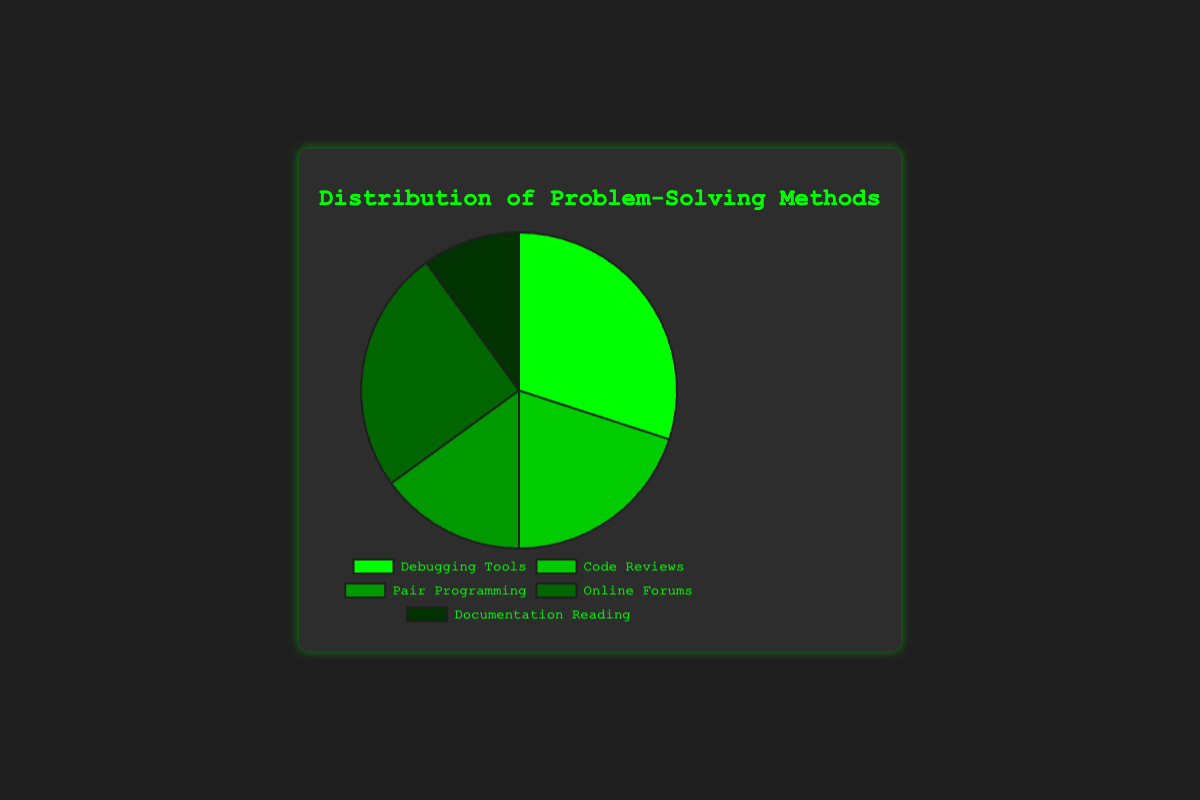What method is used least frequently? By looking at the segments of the pie chart, we can identify the smallest one. The slice representing "Documentation Reading" has the smallest proportion.
Answer: Documentation Reading What percentage of problem-solving methods are attributed to Debugging Tools and Online Forums combined? To find this, sum the percentages for Debugging Tools (30%) and Online Forums (25%): 30 + 25 = 55.
Answer: 55% Which method is used more frequently: Pair Programming or Code Reviews? By comparing the sizes of the slices for Pair Programming (15%) and Code Reviews (20%), we see that the slice for Code Reviews is larger.
Answer: Code Reviews What is the difference in percentage between the most frequently used method and the least frequently used method? The most frequently used method is Debugging Tools at 30%, and the least frequently used is Documentation Reading at 10%. The difference is 30 - 10 = 20.
Answer: 20% What visual attribute helps indicate the methods using similar color shades? The methods represented by similar shades of green can help identify them visually. For example, Debugging Tools and Code Reviews have adjacent shades of green, indicating related methods.
Answer: shades of green Which two methods combined account for half of the problem-solving methods used? Determine which pairs of methods sum to 50%. Debugging Tools (30%) and Online Forums (25%) together account for more than half. For exactly half: Code Reviews (20%) and Online Forums (25%) sum to 45%, which is closest to half.
Answer: Debugging Tools and Pair Programming If you were to redistribute 5% from Online Forums to Documentation Reading, what would the new percentages be for these two methods? Subtract 5% from Online Forums (25 - 5 = 20) and add 5% to Documentation Reading (10 + 5 = 15).
Answer: Online Forums: 20%, Documentation Reading: 15% How many methods account for more than 20% of problem-solving methods each? From the chart, only Debugging Tools (30%) and Online Forums (25%) are above 20%. So, two methods account for more than 20% each.
Answer: 2 What percentage more are Debugging Tools used compared to Pair Programming? The percentage for Debugging Tools is 30% and for Pair Programming is 15%. The difference is 30 - 15 = 15, thus Debugging Tools are used 15% more than Pair Programming.
Answer: 15% 